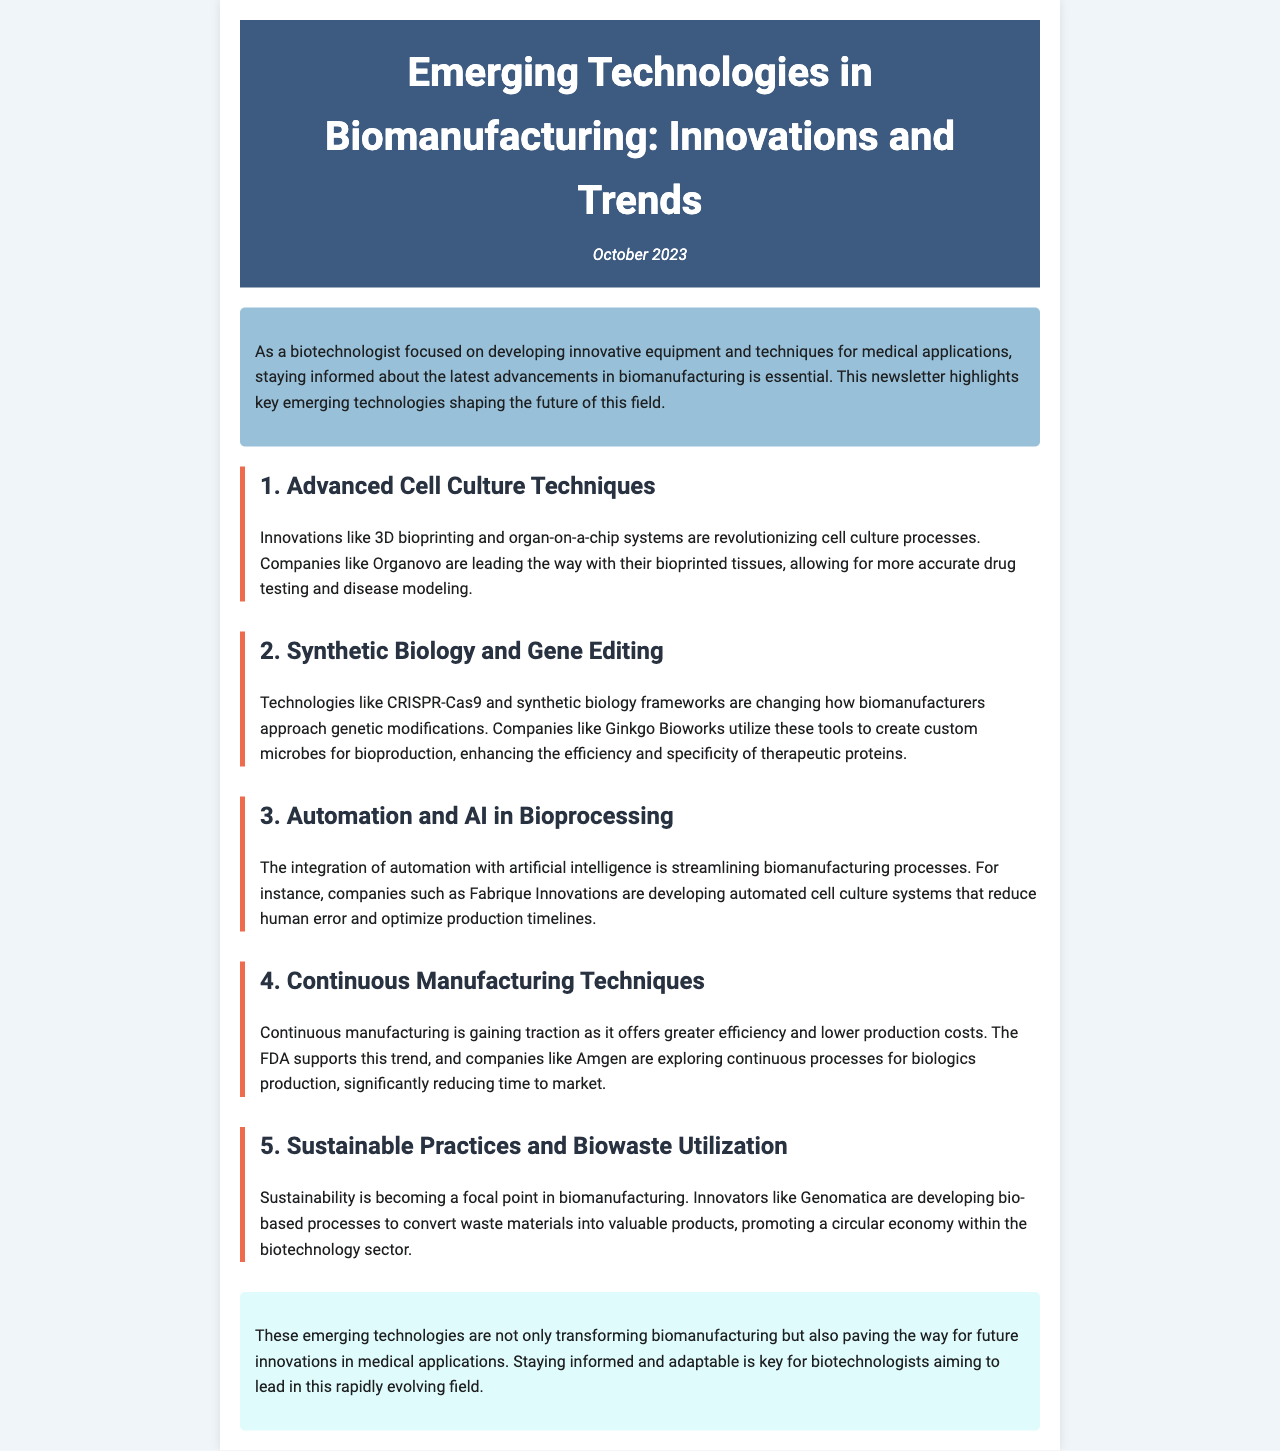What is the title of the newsletter? The title is prominently displayed at the top of the document, summarizing the main focus of the content.
Answer: Emerging Technologies in Biomanufacturing: Innovations and Trends In which month and year was this newsletter published? The date of publication is indicated just below the title, providing a time reference for the content.
Answer: October 2023 What company is mentioned as leading in bioprinted tissues? This company is specifically highlighted in the section about advanced cell culture techniques, showcasing a key player in that field.
Answer: Organovo Which technology is used for genetic modifications according to the document? The document presents this technology in the context of synthetic biology and gene editing, indicating its significance.
Answer: CRISPR-Cas9 Which company is exploring continuous processes for biologics production? This company is referenced in the section on continuous manufacturing techniques, illustrating industry movement towards efficiency.
Answer: Amgen What key focus is becoming important in biomanufacturing according to the newsletter? The document emphasizes this trend in the section discussing sustainable practices and biowaste utilization.
Answer: Sustainability What process is described as reducing human error in biomanufacturing? The document discusses this integration in the automation section, highlighting advancements that help streamline operations.
Answer: Automated cell culture systems What is a benefit of continuous manufacturing mentioned in the newsletter? The document mentions this specific advantage when discussing the trend of continuous manufacturing in the respective section.
Answer: Greater efficiency What are bio-based processes aimed at according to Genomatica's innovations? This goal is established in relation to waste material conversion, offering insight into the broader impacts of innovation in the field.
Answer: Promoting a circular economy 